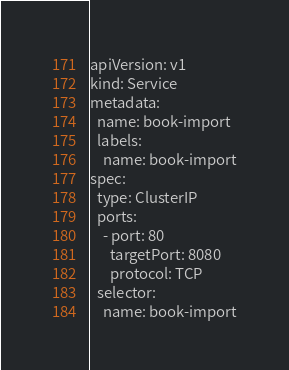<code> <loc_0><loc_0><loc_500><loc_500><_YAML_>apiVersion: v1
kind: Service
metadata:
  name: book-import
  labels:
    name: book-import
spec:
  type: ClusterIP
  ports:
    - port: 80
      targetPort: 8080
      protocol: TCP
  selector:
    name: book-import</code> 